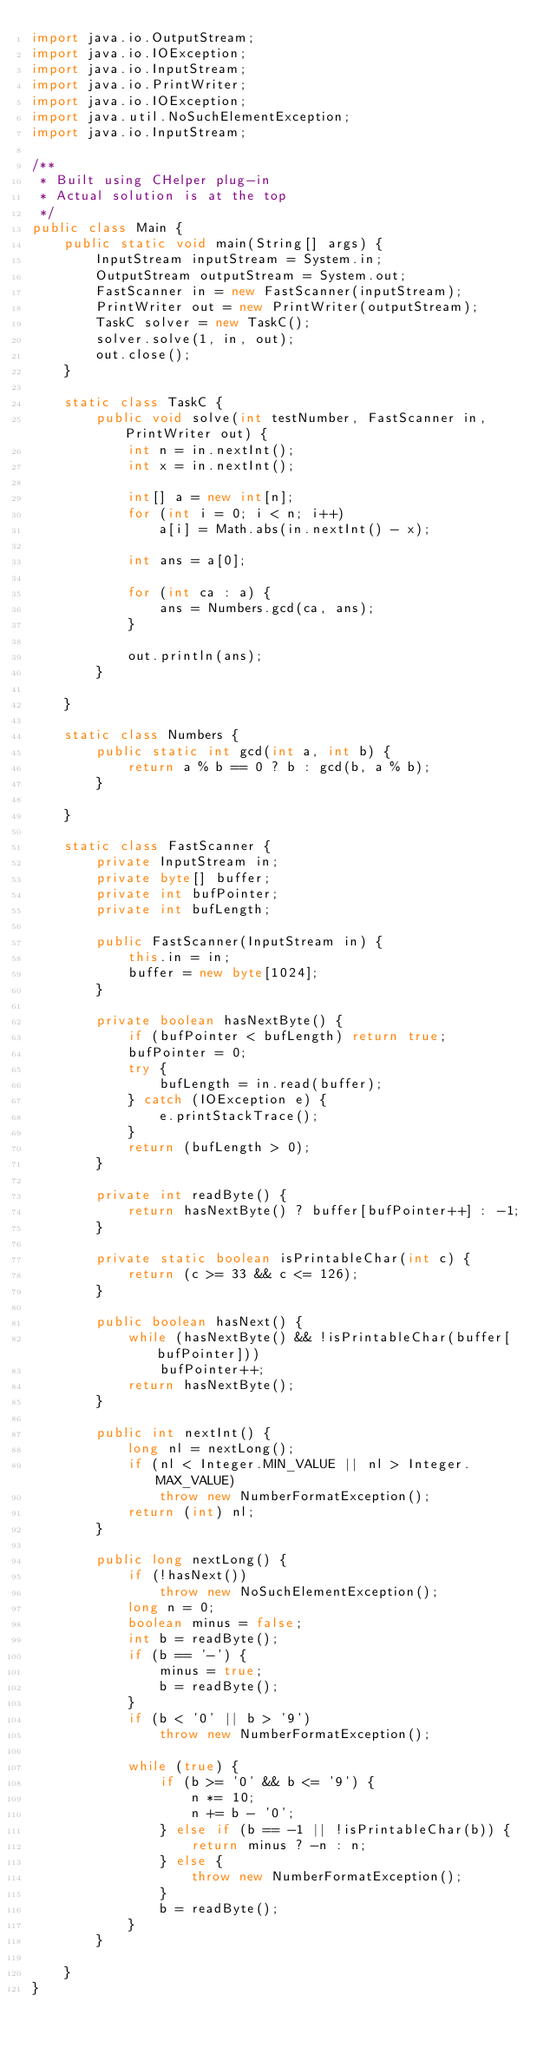Convert code to text. <code><loc_0><loc_0><loc_500><loc_500><_Java_>import java.io.OutputStream;
import java.io.IOException;
import java.io.InputStream;
import java.io.PrintWriter;
import java.io.IOException;
import java.util.NoSuchElementException;
import java.io.InputStream;

/**
 * Built using CHelper plug-in
 * Actual solution is at the top
 */
public class Main {
    public static void main(String[] args) {
        InputStream inputStream = System.in;
        OutputStream outputStream = System.out;
        FastScanner in = new FastScanner(inputStream);
        PrintWriter out = new PrintWriter(outputStream);
        TaskC solver = new TaskC();
        solver.solve(1, in, out);
        out.close();
    }

    static class TaskC {
        public void solve(int testNumber, FastScanner in, PrintWriter out) {
            int n = in.nextInt();
            int x = in.nextInt();

            int[] a = new int[n];
            for (int i = 0; i < n; i++)
                a[i] = Math.abs(in.nextInt() - x);

            int ans = a[0];

            for (int ca : a) {
                ans = Numbers.gcd(ca, ans);
            }

            out.println(ans);
        }

    }

    static class Numbers {
        public static int gcd(int a, int b) {
            return a % b == 0 ? b : gcd(b, a % b);
        }

    }

    static class FastScanner {
        private InputStream in;
        private byte[] buffer;
        private int bufPointer;
        private int bufLength;

        public FastScanner(InputStream in) {
            this.in = in;
            buffer = new byte[1024];
        }

        private boolean hasNextByte() {
            if (bufPointer < bufLength) return true;
            bufPointer = 0;
            try {
                bufLength = in.read(buffer);
            } catch (IOException e) {
                e.printStackTrace();
            }
            return (bufLength > 0);
        }

        private int readByte() {
            return hasNextByte() ? buffer[bufPointer++] : -1;
        }

        private static boolean isPrintableChar(int c) {
            return (c >= 33 && c <= 126);
        }

        public boolean hasNext() {
            while (hasNextByte() && !isPrintableChar(buffer[bufPointer]))
                bufPointer++;
            return hasNextByte();
        }

        public int nextInt() {
            long nl = nextLong();
            if (nl < Integer.MIN_VALUE || nl > Integer.MAX_VALUE)
                throw new NumberFormatException();
            return (int) nl;
        }

        public long nextLong() {
            if (!hasNext())
                throw new NoSuchElementException();
            long n = 0;
            boolean minus = false;
            int b = readByte();
            if (b == '-') {
                minus = true;
                b = readByte();
            }
            if (b < '0' || b > '9')
                throw new NumberFormatException();

            while (true) {
                if (b >= '0' && b <= '9') {
                    n *= 10;
                    n += b - '0';
                } else if (b == -1 || !isPrintableChar(b)) {
                    return minus ? -n : n;
                } else {
                    throw new NumberFormatException();
                }
                b = readByte();
            }
        }

    }
}

</code> 